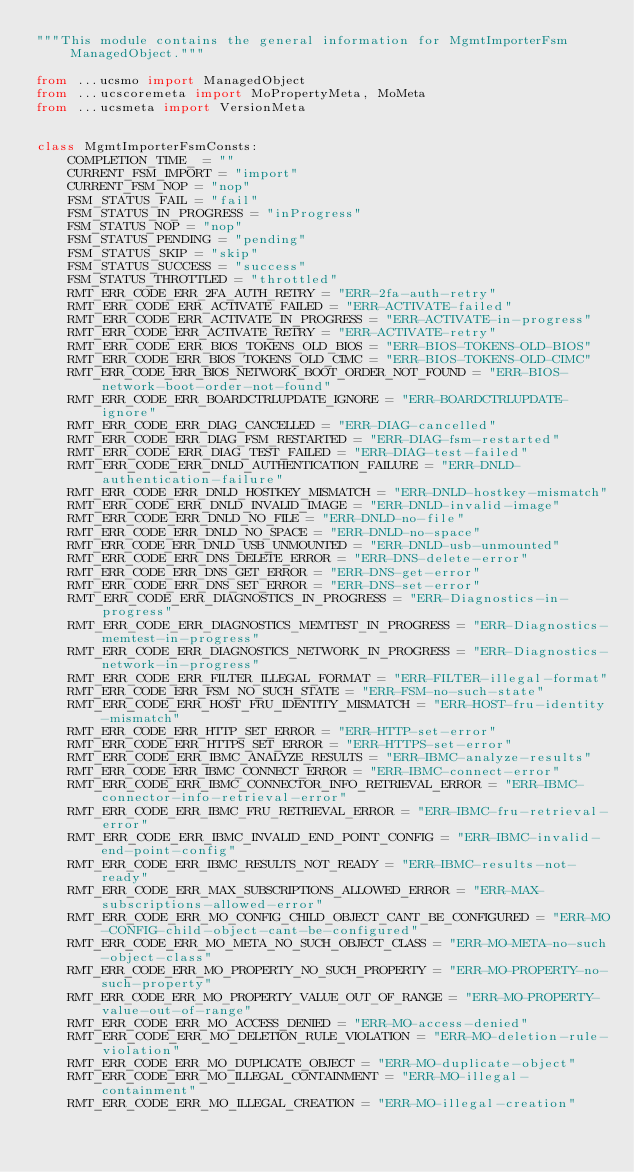<code> <loc_0><loc_0><loc_500><loc_500><_Python_>"""This module contains the general information for MgmtImporterFsm ManagedObject."""

from ...ucsmo import ManagedObject
from ...ucscoremeta import MoPropertyMeta, MoMeta
from ...ucsmeta import VersionMeta


class MgmtImporterFsmConsts:
    COMPLETION_TIME_ = ""
    CURRENT_FSM_IMPORT = "import"
    CURRENT_FSM_NOP = "nop"
    FSM_STATUS_FAIL = "fail"
    FSM_STATUS_IN_PROGRESS = "inProgress"
    FSM_STATUS_NOP = "nop"
    FSM_STATUS_PENDING = "pending"
    FSM_STATUS_SKIP = "skip"
    FSM_STATUS_SUCCESS = "success"
    FSM_STATUS_THROTTLED = "throttled"
    RMT_ERR_CODE_ERR_2FA_AUTH_RETRY = "ERR-2fa-auth-retry"
    RMT_ERR_CODE_ERR_ACTIVATE_FAILED = "ERR-ACTIVATE-failed"
    RMT_ERR_CODE_ERR_ACTIVATE_IN_PROGRESS = "ERR-ACTIVATE-in-progress"
    RMT_ERR_CODE_ERR_ACTIVATE_RETRY = "ERR-ACTIVATE-retry"
    RMT_ERR_CODE_ERR_BIOS_TOKENS_OLD_BIOS = "ERR-BIOS-TOKENS-OLD-BIOS"
    RMT_ERR_CODE_ERR_BIOS_TOKENS_OLD_CIMC = "ERR-BIOS-TOKENS-OLD-CIMC"
    RMT_ERR_CODE_ERR_BIOS_NETWORK_BOOT_ORDER_NOT_FOUND = "ERR-BIOS-network-boot-order-not-found"
    RMT_ERR_CODE_ERR_BOARDCTRLUPDATE_IGNORE = "ERR-BOARDCTRLUPDATE-ignore"
    RMT_ERR_CODE_ERR_DIAG_CANCELLED = "ERR-DIAG-cancelled"
    RMT_ERR_CODE_ERR_DIAG_FSM_RESTARTED = "ERR-DIAG-fsm-restarted"
    RMT_ERR_CODE_ERR_DIAG_TEST_FAILED = "ERR-DIAG-test-failed"
    RMT_ERR_CODE_ERR_DNLD_AUTHENTICATION_FAILURE = "ERR-DNLD-authentication-failure"
    RMT_ERR_CODE_ERR_DNLD_HOSTKEY_MISMATCH = "ERR-DNLD-hostkey-mismatch"
    RMT_ERR_CODE_ERR_DNLD_INVALID_IMAGE = "ERR-DNLD-invalid-image"
    RMT_ERR_CODE_ERR_DNLD_NO_FILE = "ERR-DNLD-no-file"
    RMT_ERR_CODE_ERR_DNLD_NO_SPACE = "ERR-DNLD-no-space"
    RMT_ERR_CODE_ERR_DNLD_USB_UNMOUNTED = "ERR-DNLD-usb-unmounted"
    RMT_ERR_CODE_ERR_DNS_DELETE_ERROR = "ERR-DNS-delete-error"
    RMT_ERR_CODE_ERR_DNS_GET_ERROR = "ERR-DNS-get-error"
    RMT_ERR_CODE_ERR_DNS_SET_ERROR = "ERR-DNS-set-error"
    RMT_ERR_CODE_ERR_DIAGNOSTICS_IN_PROGRESS = "ERR-Diagnostics-in-progress"
    RMT_ERR_CODE_ERR_DIAGNOSTICS_MEMTEST_IN_PROGRESS = "ERR-Diagnostics-memtest-in-progress"
    RMT_ERR_CODE_ERR_DIAGNOSTICS_NETWORK_IN_PROGRESS = "ERR-Diagnostics-network-in-progress"
    RMT_ERR_CODE_ERR_FILTER_ILLEGAL_FORMAT = "ERR-FILTER-illegal-format"
    RMT_ERR_CODE_ERR_FSM_NO_SUCH_STATE = "ERR-FSM-no-such-state"
    RMT_ERR_CODE_ERR_HOST_FRU_IDENTITY_MISMATCH = "ERR-HOST-fru-identity-mismatch"
    RMT_ERR_CODE_ERR_HTTP_SET_ERROR = "ERR-HTTP-set-error"
    RMT_ERR_CODE_ERR_HTTPS_SET_ERROR = "ERR-HTTPS-set-error"
    RMT_ERR_CODE_ERR_IBMC_ANALYZE_RESULTS = "ERR-IBMC-analyze-results"
    RMT_ERR_CODE_ERR_IBMC_CONNECT_ERROR = "ERR-IBMC-connect-error"
    RMT_ERR_CODE_ERR_IBMC_CONNECTOR_INFO_RETRIEVAL_ERROR = "ERR-IBMC-connector-info-retrieval-error"
    RMT_ERR_CODE_ERR_IBMC_FRU_RETRIEVAL_ERROR = "ERR-IBMC-fru-retrieval-error"
    RMT_ERR_CODE_ERR_IBMC_INVALID_END_POINT_CONFIG = "ERR-IBMC-invalid-end-point-config"
    RMT_ERR_CODE_ERR_IBMC_RESULTS_NOT_READY = "ERR-IBMC-results-not-ready"
    RMT_ERR_CODE_ERR_MAX_SUBSCRIPTIONS_ALLOWED_ERROR = "ERR-MAX-subscriptions-allowed-error"
    RMT_ERR_CODE_ERR_MO_CONFIG_CHILD_OBJECT_CANT_BE_CONFIGURED = "ERR-MO-CONFIG-child-object-cant-be-configured"
    RMT_ERR_CODE_ERR_MO_META_NO_SUCH_OBJECT_CLASS = "ERR-MO-META-no-such-object-class"
    RMT_ERR_CODE_ERR_MO_PROPERTY_NO_SUCH_PROPERTY = "ERR-MO-PROPERTY-no-such-property"
    RMT_ERR_CODE_ERR_MO_PROPERTY_VALUE_OUT_OF_RANGE = "ERR-MO-PROPERTY-value-out-of-range"
    RMT_ERR_CODE_ERR_MO_ACCESS_DENIED = "ERR-MO-access-denied"
    RMT_ERR_CODE_ERR_MO_DELETION_RULE_VIOLATION = "ERR-MO-deletion-rule-violation"
    RMT_ERR_CODE_ERR_MO_DUPLICATE_OBJECT = "ERR-MO-duplicate-object"
    RMT_ERR_CODE_ERR_MO_ILLEGAL_CONTAINMENT = "ERR-MO-illegal-containment"
    RMT_ERR_CODE_ERR_MO_ILLEGAL_CREATION = "ERR-MO-illegal-creation"</code> 